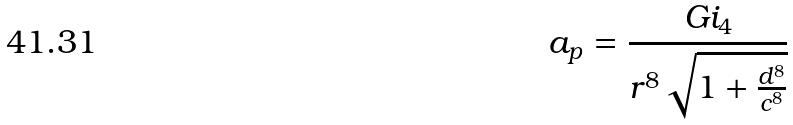Convert formula to latex. <formula><loc_0><loc_0><loc_500><loc_500>a _ { p } = \frac { G i _ { 4 } } { r ^ { 8 } \sqrt { 1 + \frac { d ^ { 8 } } { c ^ { 8 } } } }</formula> 